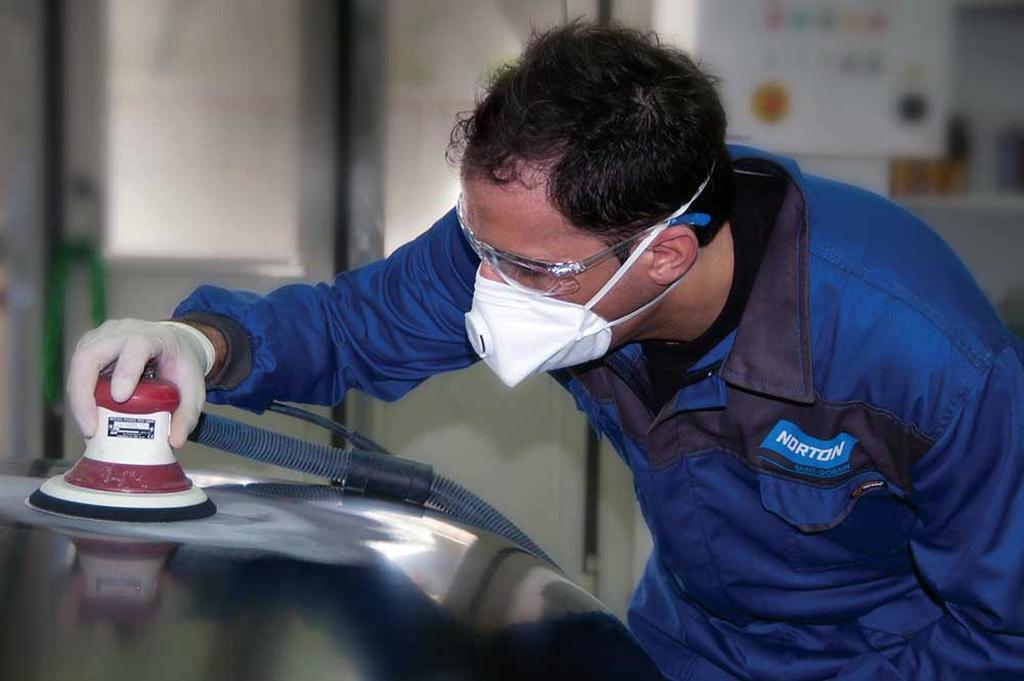Can you describe this image briefly? In the image there is a person with a face mask and goggles is bending. He is holding an object which is in white and red color and attached with a pipe. Behind him there is a blur background and also there is a door and a paper attached to the wall. 